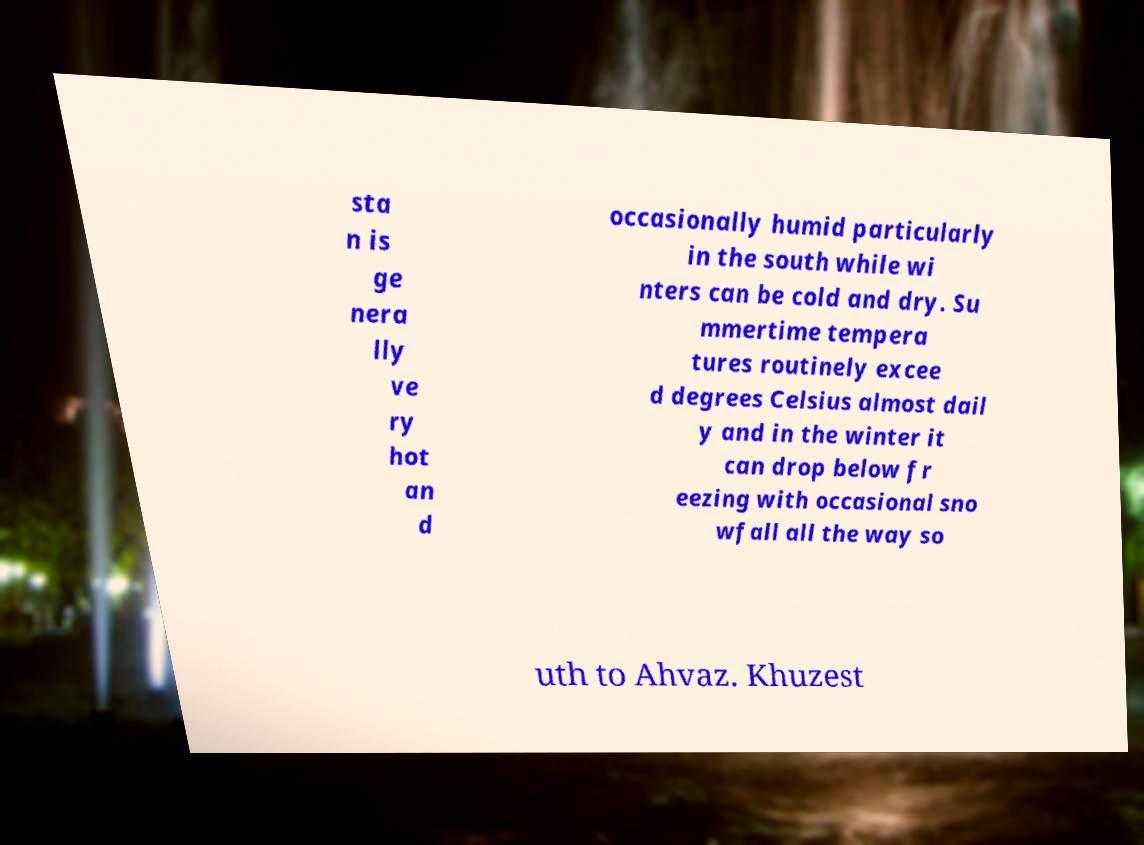Could you assist in decoding the text presented in this image and type it out clearly? sta n is ge nera lly ve ry hot an d occasionally humid particularly in the south while wi nters can be cold and dry. Su mmertime tempera tures routinely excee d degrees Celsius almost dail y and in the winter it can drop below fr eezing with occasional sno wfall all the way so uth to Ahvaz. Khuzest 